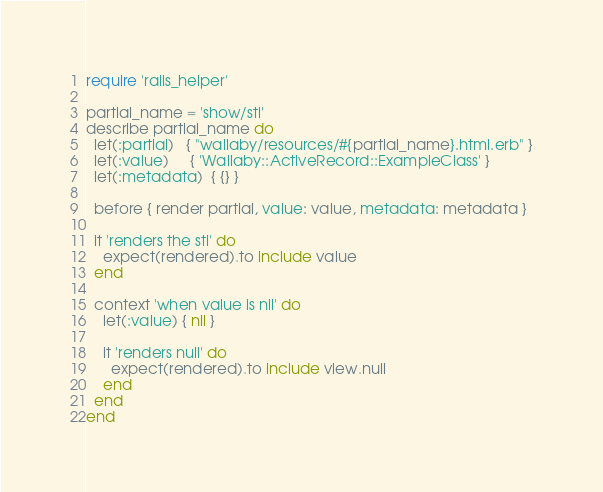<code> <loc_0><loc_0><loc_500><loc_500><_Ruby_>require 'rails_helper'

partial_name = 'show/sti'
describe partial_name do
  let(:partial)   { "wallaby/resources/#{partial_name}.html.erb" }
  let(:value)     { 'Wallaby::ActiveRecord::ExampleClass' }
  let(:metadata)  { {} }

  before { render partial, value: value, metadata: metadata }

  it 'renders the sti' do
    expect(rendered).to include value
  end

  context 'when value is nil' do
    let(:value) { nil }

    it 'renders null' do
      expect(rendered).to include view.null
    end
  end
end
</code> 